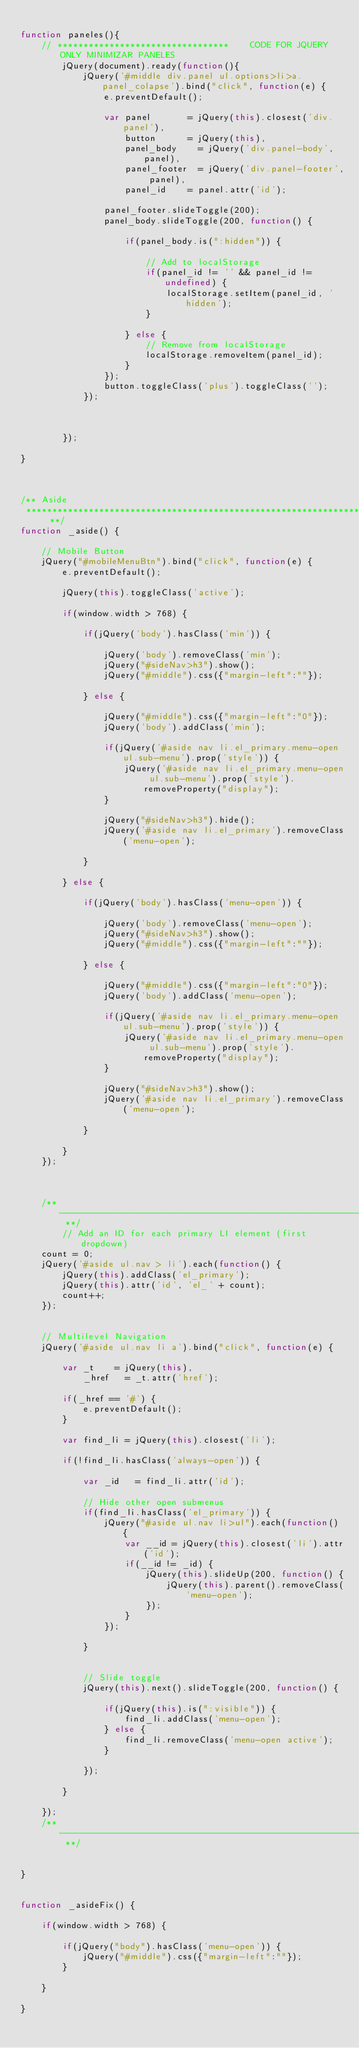<code> <loc_0><loc_0><loc_500><loc_500><_JavaScript_>
function paneles(){
    // *********************************    CODE FOR JQUERY ONLY MINIMIZAR PANELES
        jQuery(document).ready(function(){
            jQuery('#middle div.panel ul.options>li>a.panel_colapse').bind("click", function(e) {
                e.preventDefault();

                var panel 			= jQuery(this).closest('div.panel'),
                    button 			= jQuery(this),
                    panel_body 		= jQuery('div.panel-body', panel),
                    panel_footer 	= jQuery('div.panel-footer', panel),
                    panel_id		= panel.attr('id');

                panel_footer.slideToggle(200);
                panel_body.slideToggle(200, function() {

                    if(panel_body.is(":hidden")) {

                        // Add to localStorage
                        if(panel_id != '' && panel_id != undefined) {
                            localStorage.setItem(panel_id, 'hidden');
                        }

                    } else {
                        // Remove from localStorage
                        localStorage.removeItem(panel_id);
                    }
                });
                button.toggleClass('plus').toggleClass('');
            });



        });

}



/** Aside
 **************************************************************** **/
function _aside() {

    // Mobile Button
    jQuery("#mobileMenuBtn").bind("click", function(e) {
        e.preventDefault();

        jQuery(this).toggleClass('active');

        if(window.width > 768) {

            if(jQuery('body').hasClass('min')) {

                jQuery('body').removeClass('min');
                jQuery("#sideNav>h3").show();
                jQuery("#middle").css({"margin-left":""});

            } else {

                jQuery("#middle").css({"margin-left":"0"});
                jQuery('body').addClass('min');

                if(jQuery('#aside nav li.el_primary.menu-open ul.sub-menu').prop('style')) {
                    jQuery('#aside nav li.el_primary.menu-open ul.sub-menu').prop('style').removeProperty("display");
                }

                jQuery("#sideNav>h3").hide();
                jQuery('#aside nav li.el_primary').removeClass('menu-open');

            }

        } else {

            if(jQuery('body').hasClass('menu-open')) {

                jQuery('body').removeClass('menu-open');
                jQuery("#sideNav>h3").show();
                jQuery("#middle").css({"margin-left":""});

            } else {

                jQuery("#middle").css({"margin-left":"0"});
                jQuery('body').addClass('menu-open');

                if(jQuery('#aside nav li.el_primary.menu-open ul.sub-menu').prop('style')) {
                    jQuery('#aside nav li.el_primary.menu-open ul.sub-menu').prop('style').removeProperty("display");
                }

                jQuery("#sideNav>h3").show();
                jQuery('#aside nav li.el_primary').removeClass('menu-open');

            }

        }
    });



    /** -------------------------------------------------------------------------------------- **/
        // Add an ID for each primary LI element (first dropdown)
    count = 0;
    jQuery('#aside ul.nav > li').each(function() {
        jQuery(this).addClass('el_primary');
        jQuery(this).attr('id', 'el_' + count);
        count++;
    });


    // Multilevel Navigation
    jQuery('#aside ul.nav li a').bind("click", function(e) {

        var _t 		= jQuery(this),
            _href 	= _t.attr('href');

        if(_href == '#') {
            e.preventDefault();
        }

        var find_li = jQuery(this).closest('li');

        if(!find_li.hasClass('always-open')) {

            var _id		= find_li.attr('id');

            // Hide other open submenus
            if(find_li.hasClass('el_primary')) {
                jQuery("#aside ul.nav li>ul").each(function() {
                    var __id = jQuery(this).closest('li').attr('id');
                    if(__id != _id) {
                        jQuery(this).slideUp(200, function() {
                            jQuery(this).parent().removeClass('menu-open');
                        });
                    }
                });

            }


            // Slide toggle
            jQuery(this).next().slideToggle(200, function() {

                if(jQuery(this).is(":visible")) {
                    find_li.addClass('menu-open');
                } else {
                    find_li.removeClass('menu-open active');
                }

            });

        }

    });
    /** -------------------------------------------------------------------------------------- **/


}


function _asideFix() {

    if(window.width > 768) {

        if(jQuery("body").hasClass('menu-open')) {
            jQuery("#middle").css({"margin-left":""});
        }

    }

}</code> 